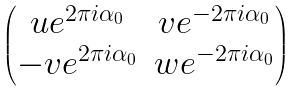<formula> <loc_0><loc_0><loc_500><loc_500>\begin{pmatrix} u e ^ { 2 \pi i \alpha _ { 0 } } & v e ^ { - 2 \pi i \alpha _ { 0 } } \\ - v e ^ { 2 \pi i \alpha _ { 0 } } & w e ^ { - 2 \pi i \alpha _ { 0 } } \end{pmatrix}</formula> 